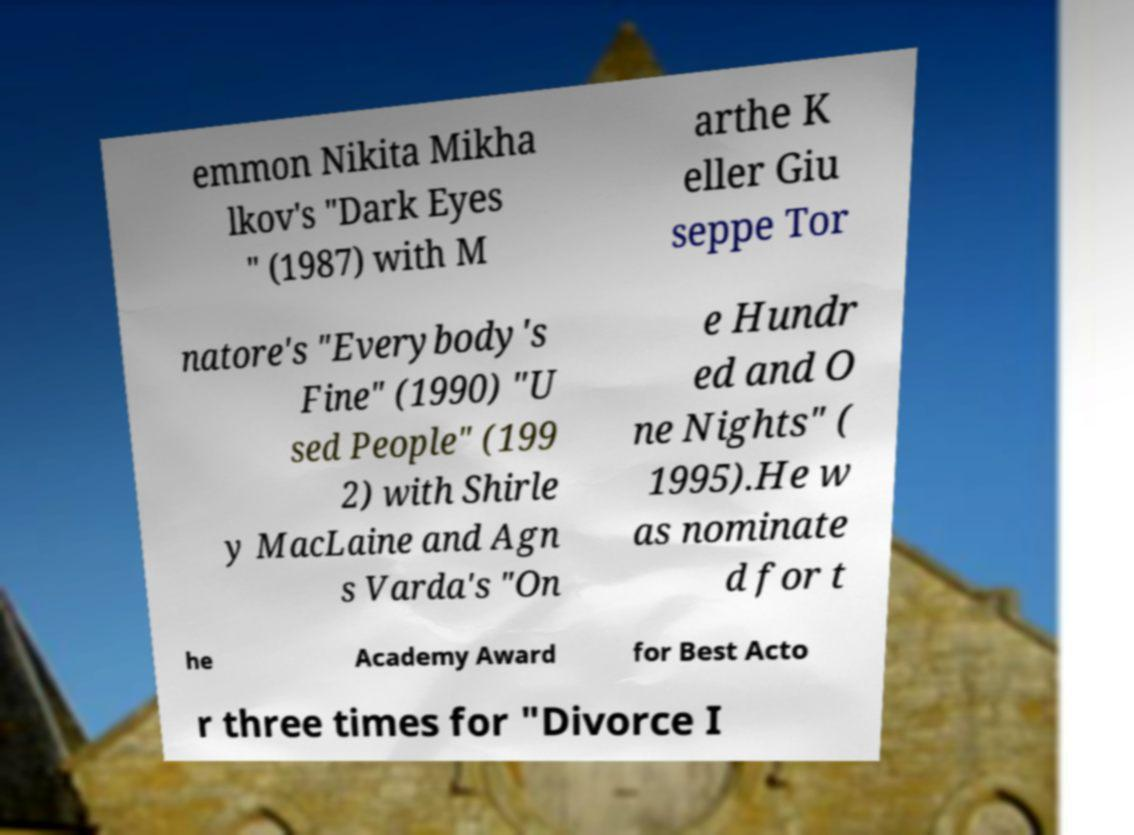What messages or text are displayed in this image? I need them in a readable, typed format. emmon Nikita Mikha lkov's "Dark Eyes " (1987) with M arthe K eller Giu seppe Tor natore's "Everybody's Fine" (1990) "U sed People" (199 2) with Shirle y MacLaine and Agn s Varda's "On e Hundr ed and O ne Nights" ( 1995).He w as nominate d for t he Academy Award for Best Acto r three times for "Divorce I 